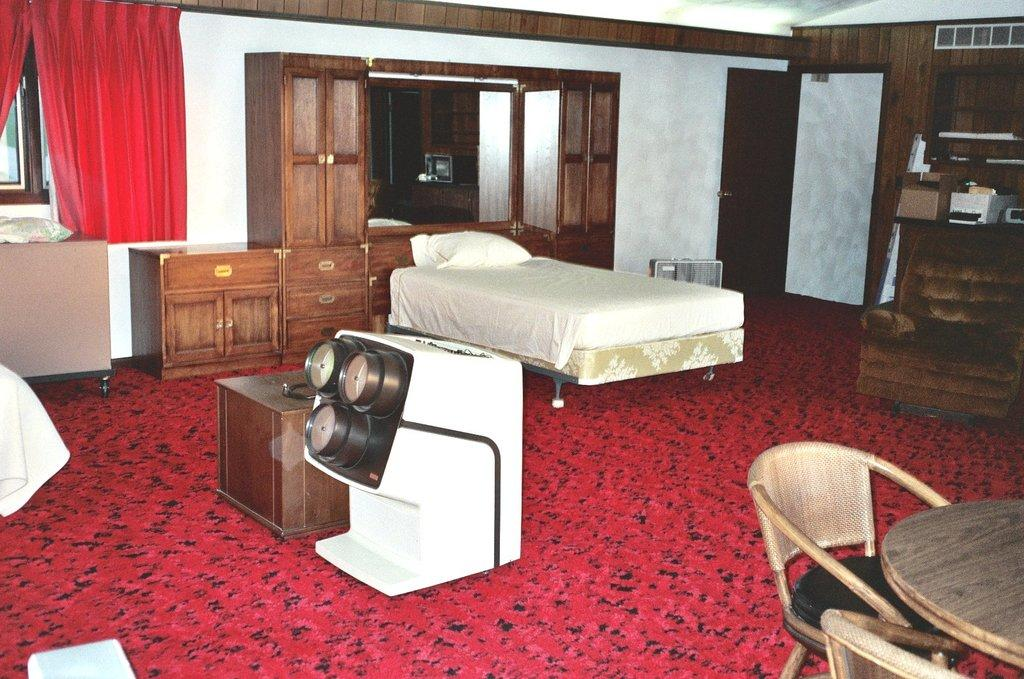What type of furniture is present in the image? There is a bed, a wardrobe, chairs, and a table in the image. What type of flooring is visible in the image? There is a red color carpet in the image. What type of window treatment is present in the image? There is a curtain in the image. How does the fork help in cleaning the dirt in the image? There is no fork present in the image, and therefore no such activity can be observed. 